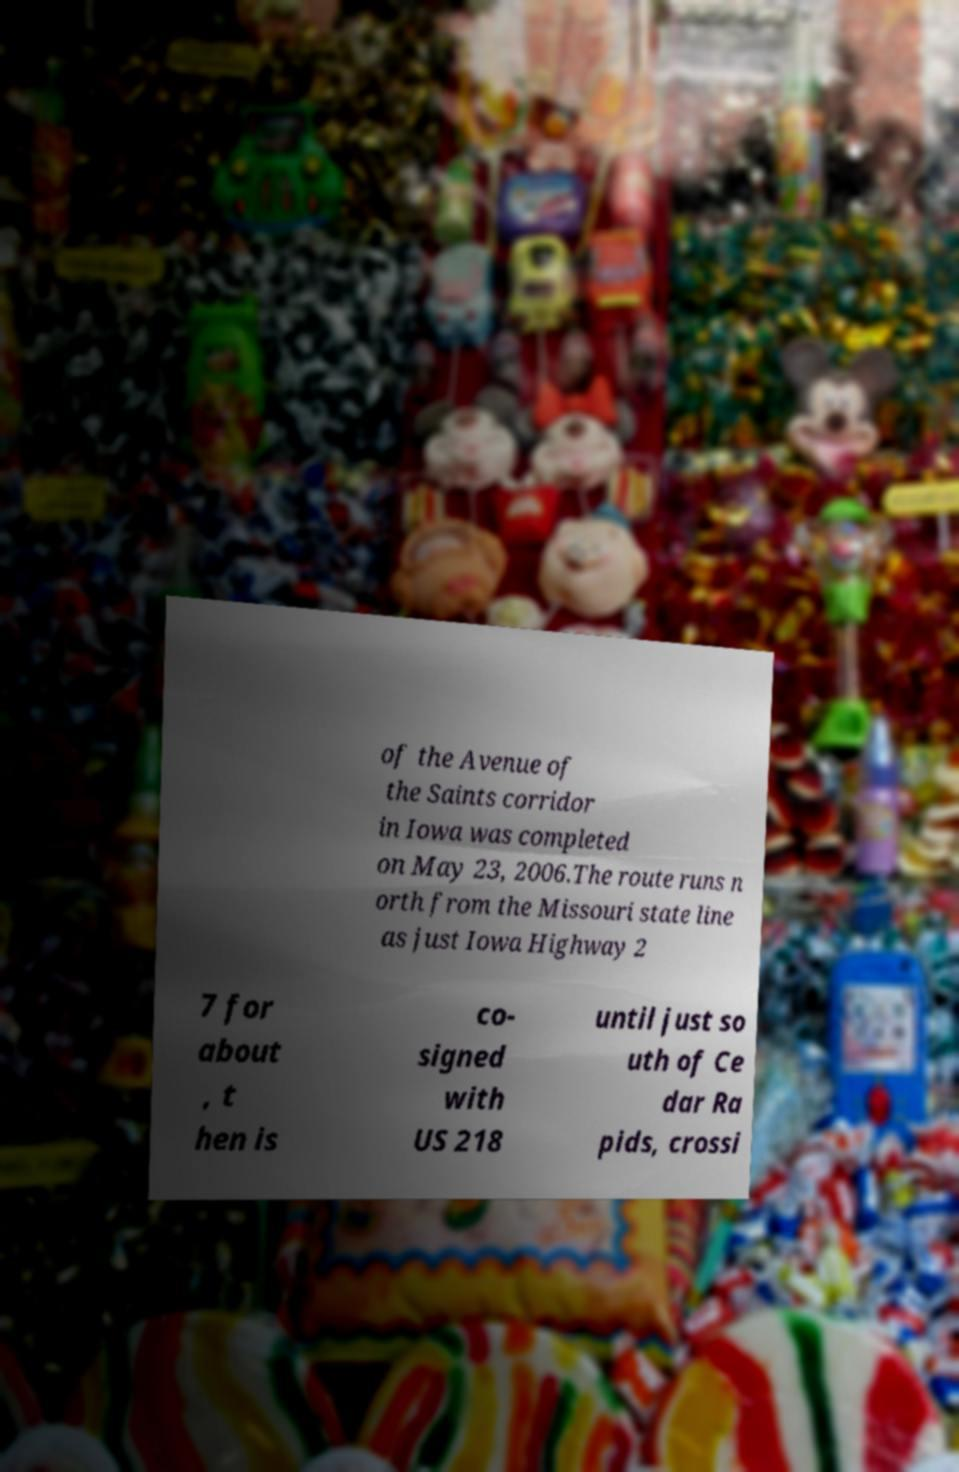Can you accurately transcribe the text from the provided image for me? of the Avenue of the Saints corridor in Iowa was completed on May 23, 2006.The route runs n orth from the Missouri state line as just Iowa Highway 2 7 for about , t hen is co- signed with US 218 until just so uth of Ce dar Ra pids, crossi 